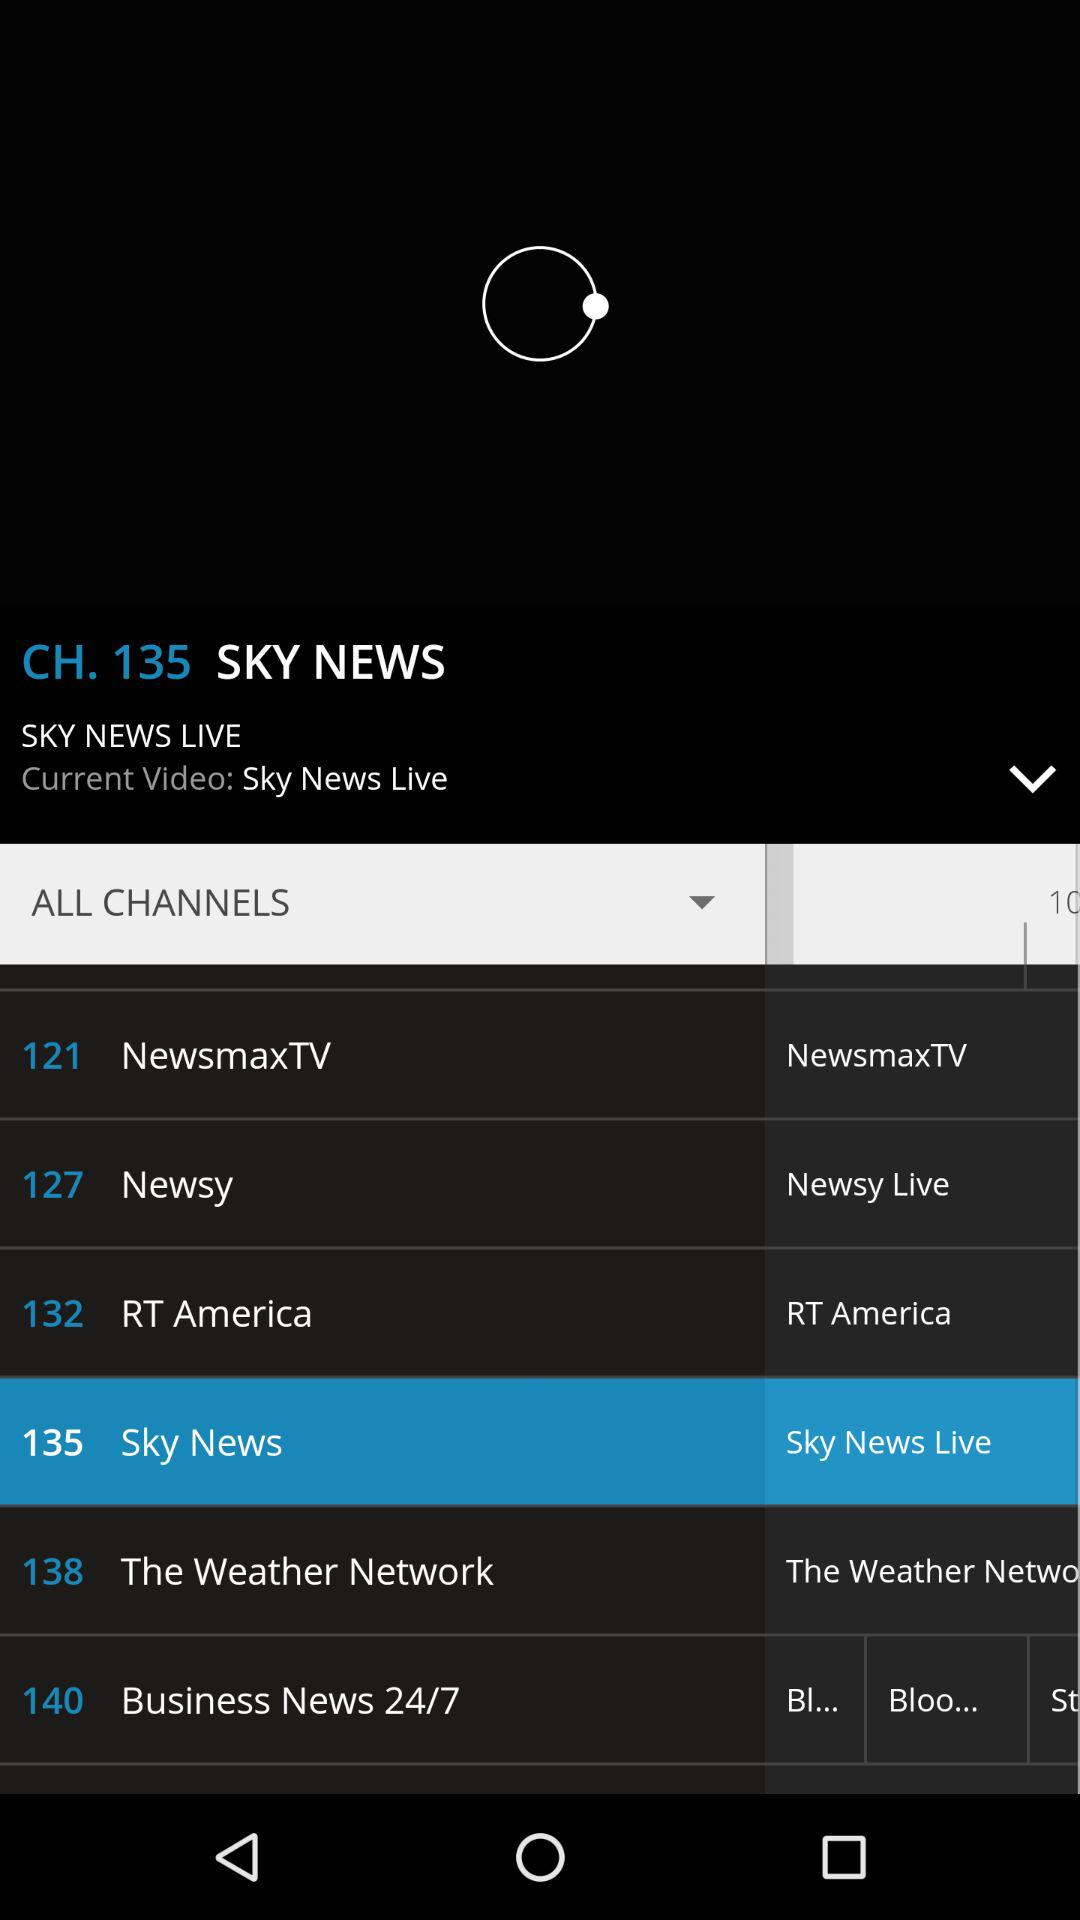What channels were selected? The selected channel was "Sky News". 